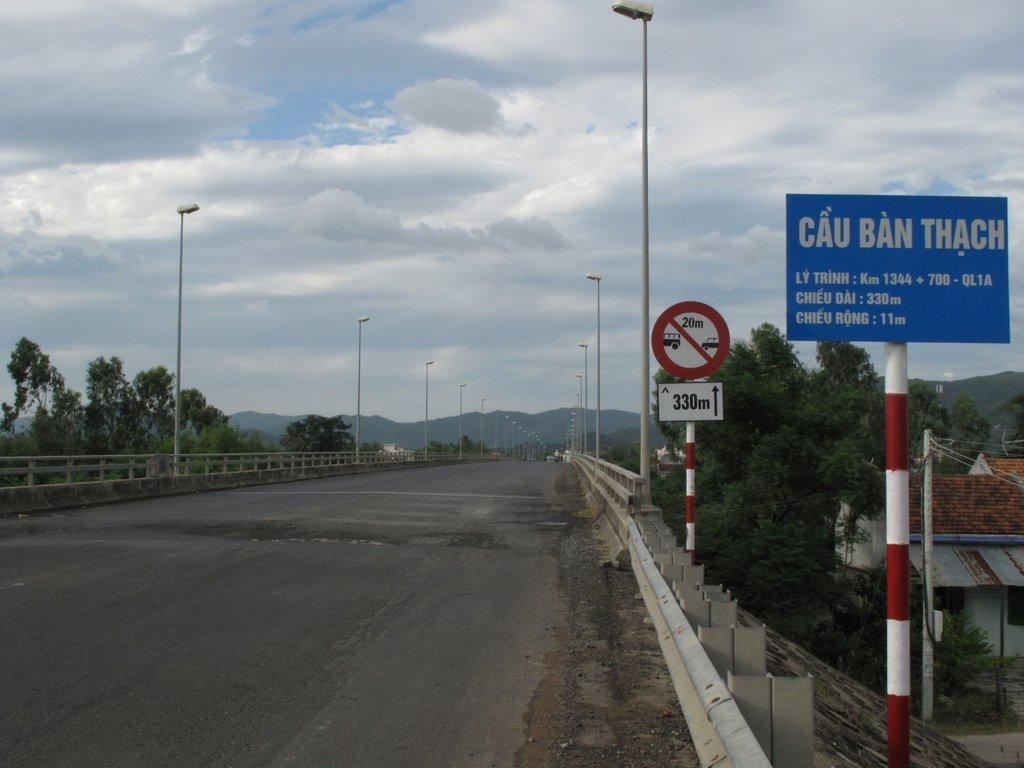<image>
Present a compact description of the photo's key features. the word Ban is on the blue sign outside 